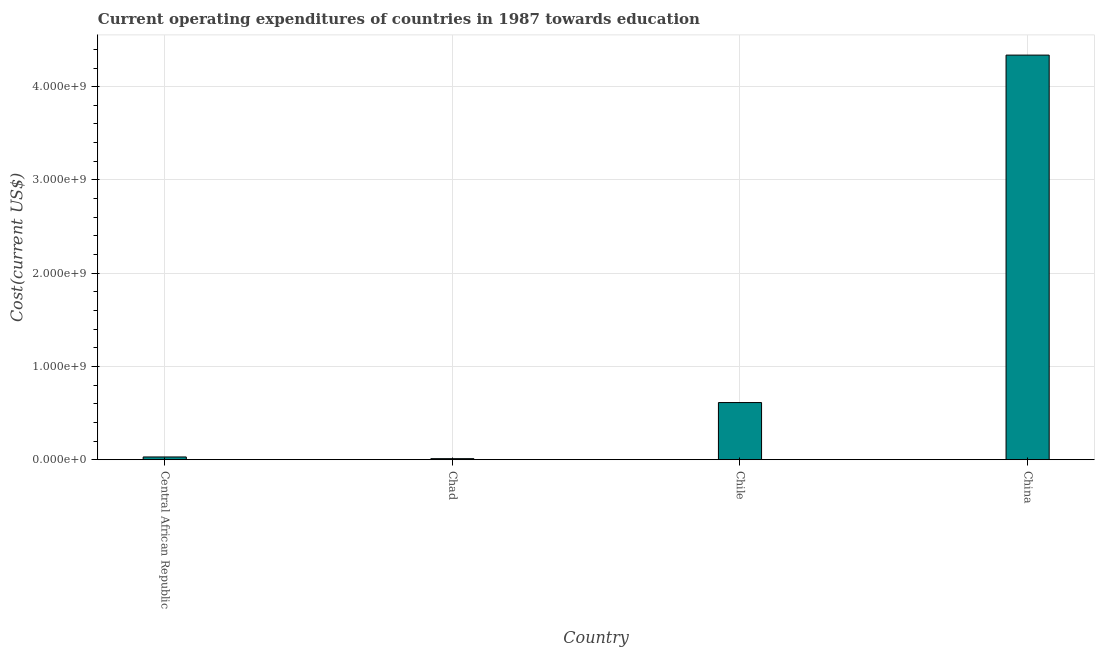Does the graph contain any zero values?
Provide a succinct answer. No. What is the title of the graph?
Your answer should be compact. Current operating expenditures of countries in 1987 towards education. What is the label or title of the Y-axis?
Provide a short and direct response. Cost(current US$). What is the education expenditure in Chile?
Make the answer very short. 6.13e+08. Across all countries, what is the maximum education expenditure?
Your answer should be compact. 4.34e+09. Across all countries, what is the minimum education expenditure?
Provide a short and direct response. 1.11e+07. In which country was the education expenditure maximum?
Offer a very short reply. China. In which country was the education expenditure minimum?
Give a very brief answer. Chad. What is the sum of the education expenditure?
Your answer should be very brief. 4.99e+09. What is the difference between the education expenditure in Chad and Chile?
Provide a succinct answer. -6.02e+08. What is the average education expenditure per country?
Keep it short and to the point. 1.25e+09. What is the median education expenditure?
Your answer should be compact. 3.21e+08. What is the ratio of the education expenditure in Central African Republic to that in Chad?
Offer a very short reply. 2.64. Is the difference between the education expenditure in Chile and China greater than the difference between any two countries?
Keep it short and to the point. No. What is the difference between the highest and the second highest education expenditure?
Provide a succinct answer. 3.73e+09. What is the difference between the highest and the lowest education expenditure?
Offer a terse response. 4.33e+09. Are all the bars in the graph horizontal?
Make the answer very short. No. How many countries are there in the graph?
Keep it short and to the point. 4. What is the Cost(current US$) of Central African Republic?
Keep it short and to the point. 2.94e+07. What is the Cost(current US$) in Chad?
Keep it short and to the point. 1.11e+07. What is the Cost(current US$) in Chile?
Ensure brevity in your answer.  6.13e+08. What is the Cost(current US$) of China?
Make the answer very short. 4.34e+09. What is the difference between the Cost(current US$) in Central African Republic and Chad?
Provide a short and direct response. 1.83e+07. What is the difference between the Cost(current US$) in Central African Republic and Chile?
Provide a short and direct response. -5.83e+08. What is the difference between the Cost(current US$) in Central African Republic and China?
Offer a terse response. -4.31e+09. What is the difference between the Cost(current US$) in Chad and Chile?
Your answer should be very brief. -6.02e+08. What is the difference between the Cost(current US$) in Chad and China?
Keep it short and to the point. -4.33e+09. What is the difference between the Cost(current US$) in Chile and China?
Your answer should be very brief. -3.73e+09. What is the ratio of the Cost(current US$) in Central African Republic to that in Chad?
Offer a very short reply. 2.64. What is the ratio of the Cost(current US$) in Central African Republic to that in Chile?
Give a very brief answer. 0.05. What is the ratio of the Cost(current US$) in Central African Republic to that in China?
Your response must be concise. 0.01. What is the ratio of the Cost(current US$) in Chad to that in Chile?
Offer a terse response. 0.02. What is the ratio of the Cost(current US$) in Chad to that in China?
Your response must be concise. 0. What is the ratio of the Cost(current US$) in Chile to that in China?
Keep it short and to the point. 0.14. 